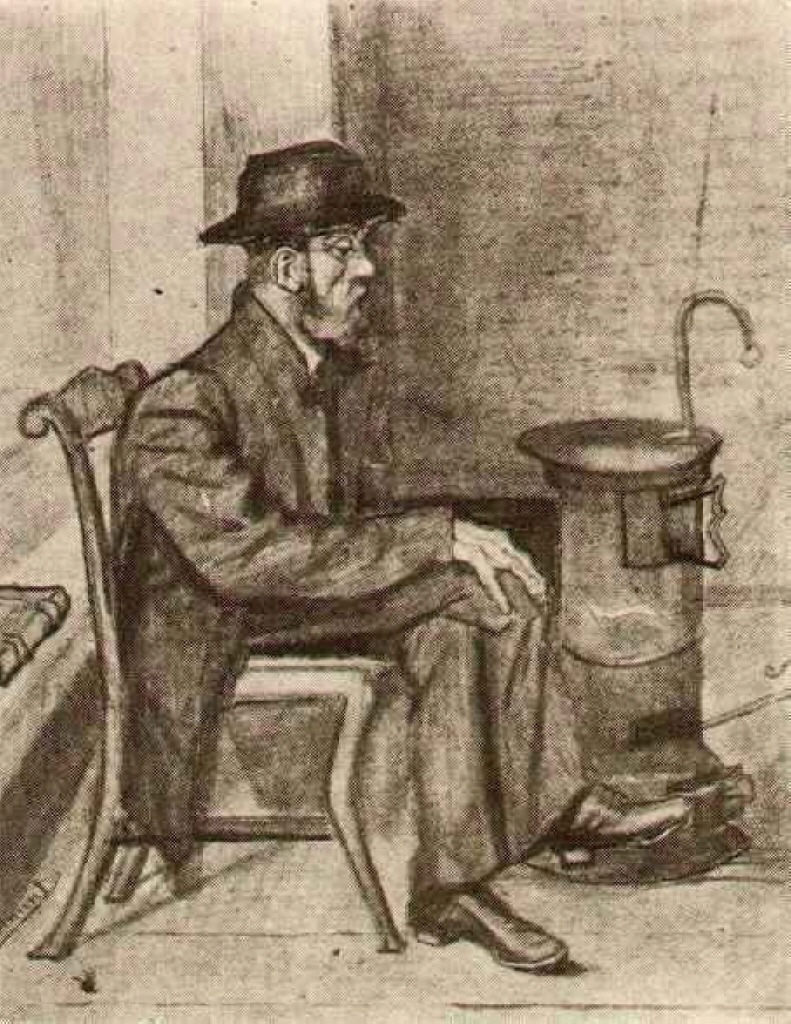What if the stove were enchanted to tell stories of the people who used it? If the stove were enchanted to tell stories, it would narrate tales of countless winters, crackling with the laughter and tears of the families it warmed. It might recount the bittersweet memories of holidays, the quiet anxieties of late-night musings, and the simple yet profound moments of everyday life. Each story would weave together the lives of different generations, capturing the enduring human spirit and the importance of small comforts in the face of life's vast challenges.  Imagine a day in this man's life. A day in this man's life likely begins with the cold bite of morning, as he rouses himself with determination. He dresses in his heavy coat and hat, ready to face a day's labor. Breakfast is a simple affair, possibly shared with a few fleeting moments of warmth from the stove. Throughout the day, he works diligently, his hands busy but his mind often wandering to past memories and future hopes. The evening brings him back to his chair by the stove, where he sits quietly, reflecting on the day's toils and finding solace in the familiar warmth. His day is a blend of physical endurance and moments of contemplative peace, marked by the resilience typical of his era. 